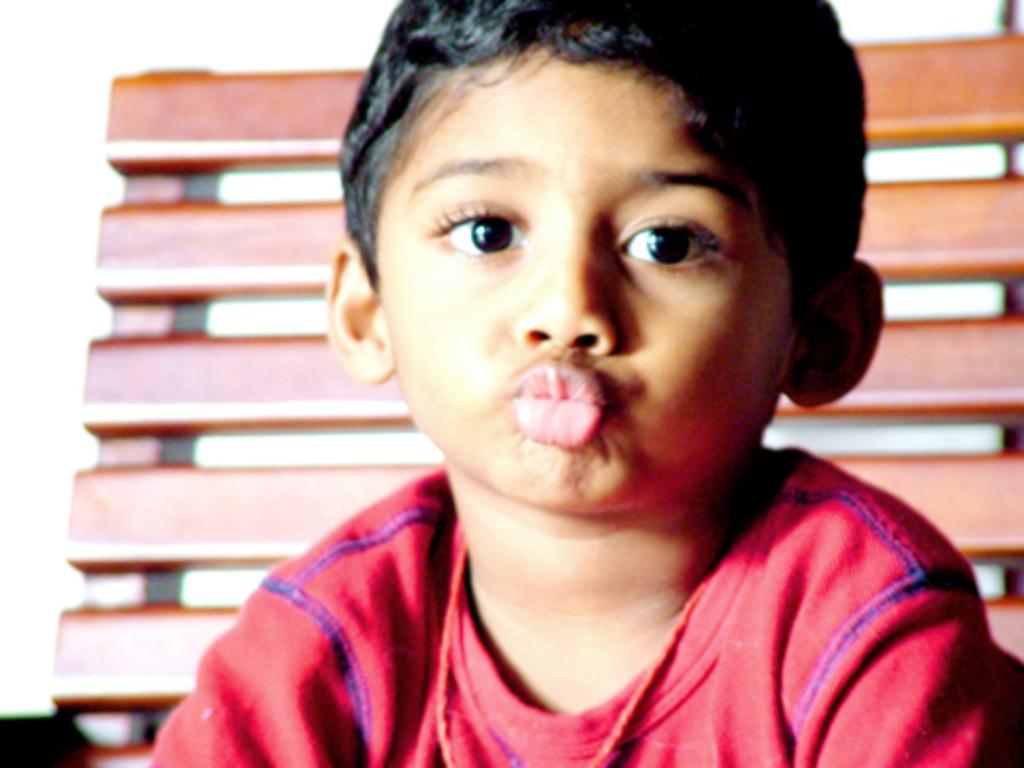Who is the main subject in the image? There is a boy in the image. What is the boy wearing? The boy is wearing a red t-shirt. Can you describe the background of the image? There may be a wooden frame behind the boy. What is the price of the tin can in the image? There is no tin can present in the image, so it is not possible to determine its price. 